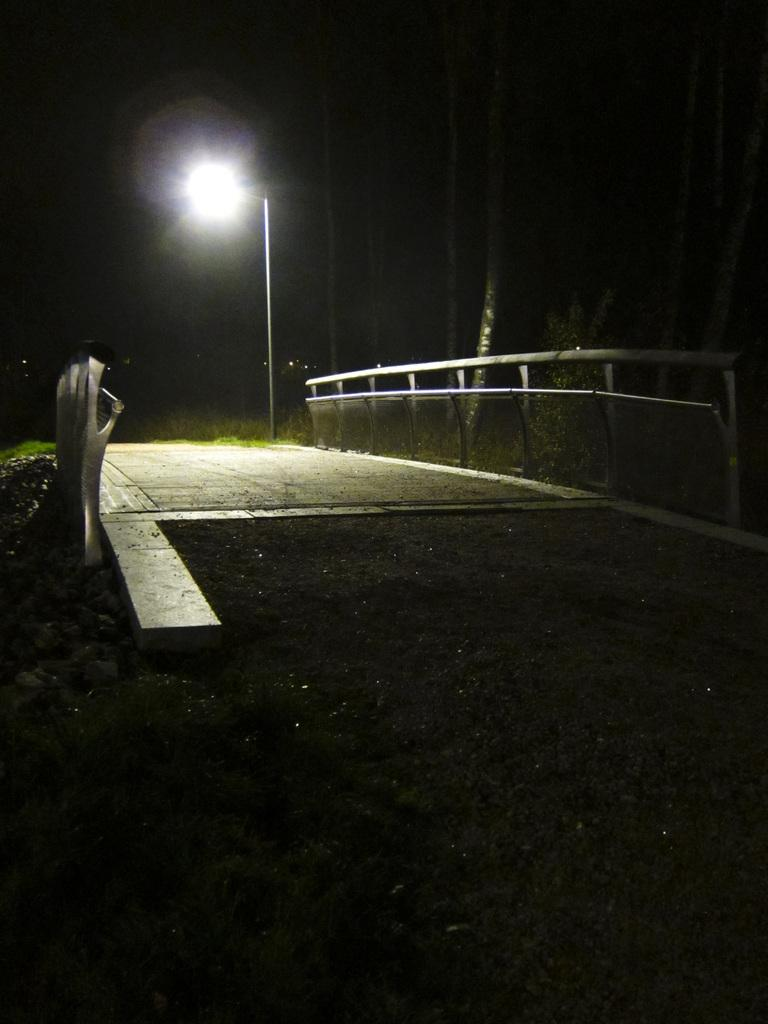What type of surface can be seen in the image? There is ground visible in the image. What structure is present in the image? There is a bridge in the image. What feature does the bridge have? The bridge has railing. What type of vegetation is in the image? There are trees in the image. What type of man-made object is in the image? There is a street light pole in the image. How would you describe the lighting in the image? The background of the image is dark. What type of receipt can be seen in the image? There is no receipt present in the image. What story is being told in the image? The image does not depict a story; it is a visual representation of a bridge, trees, and other elements. 